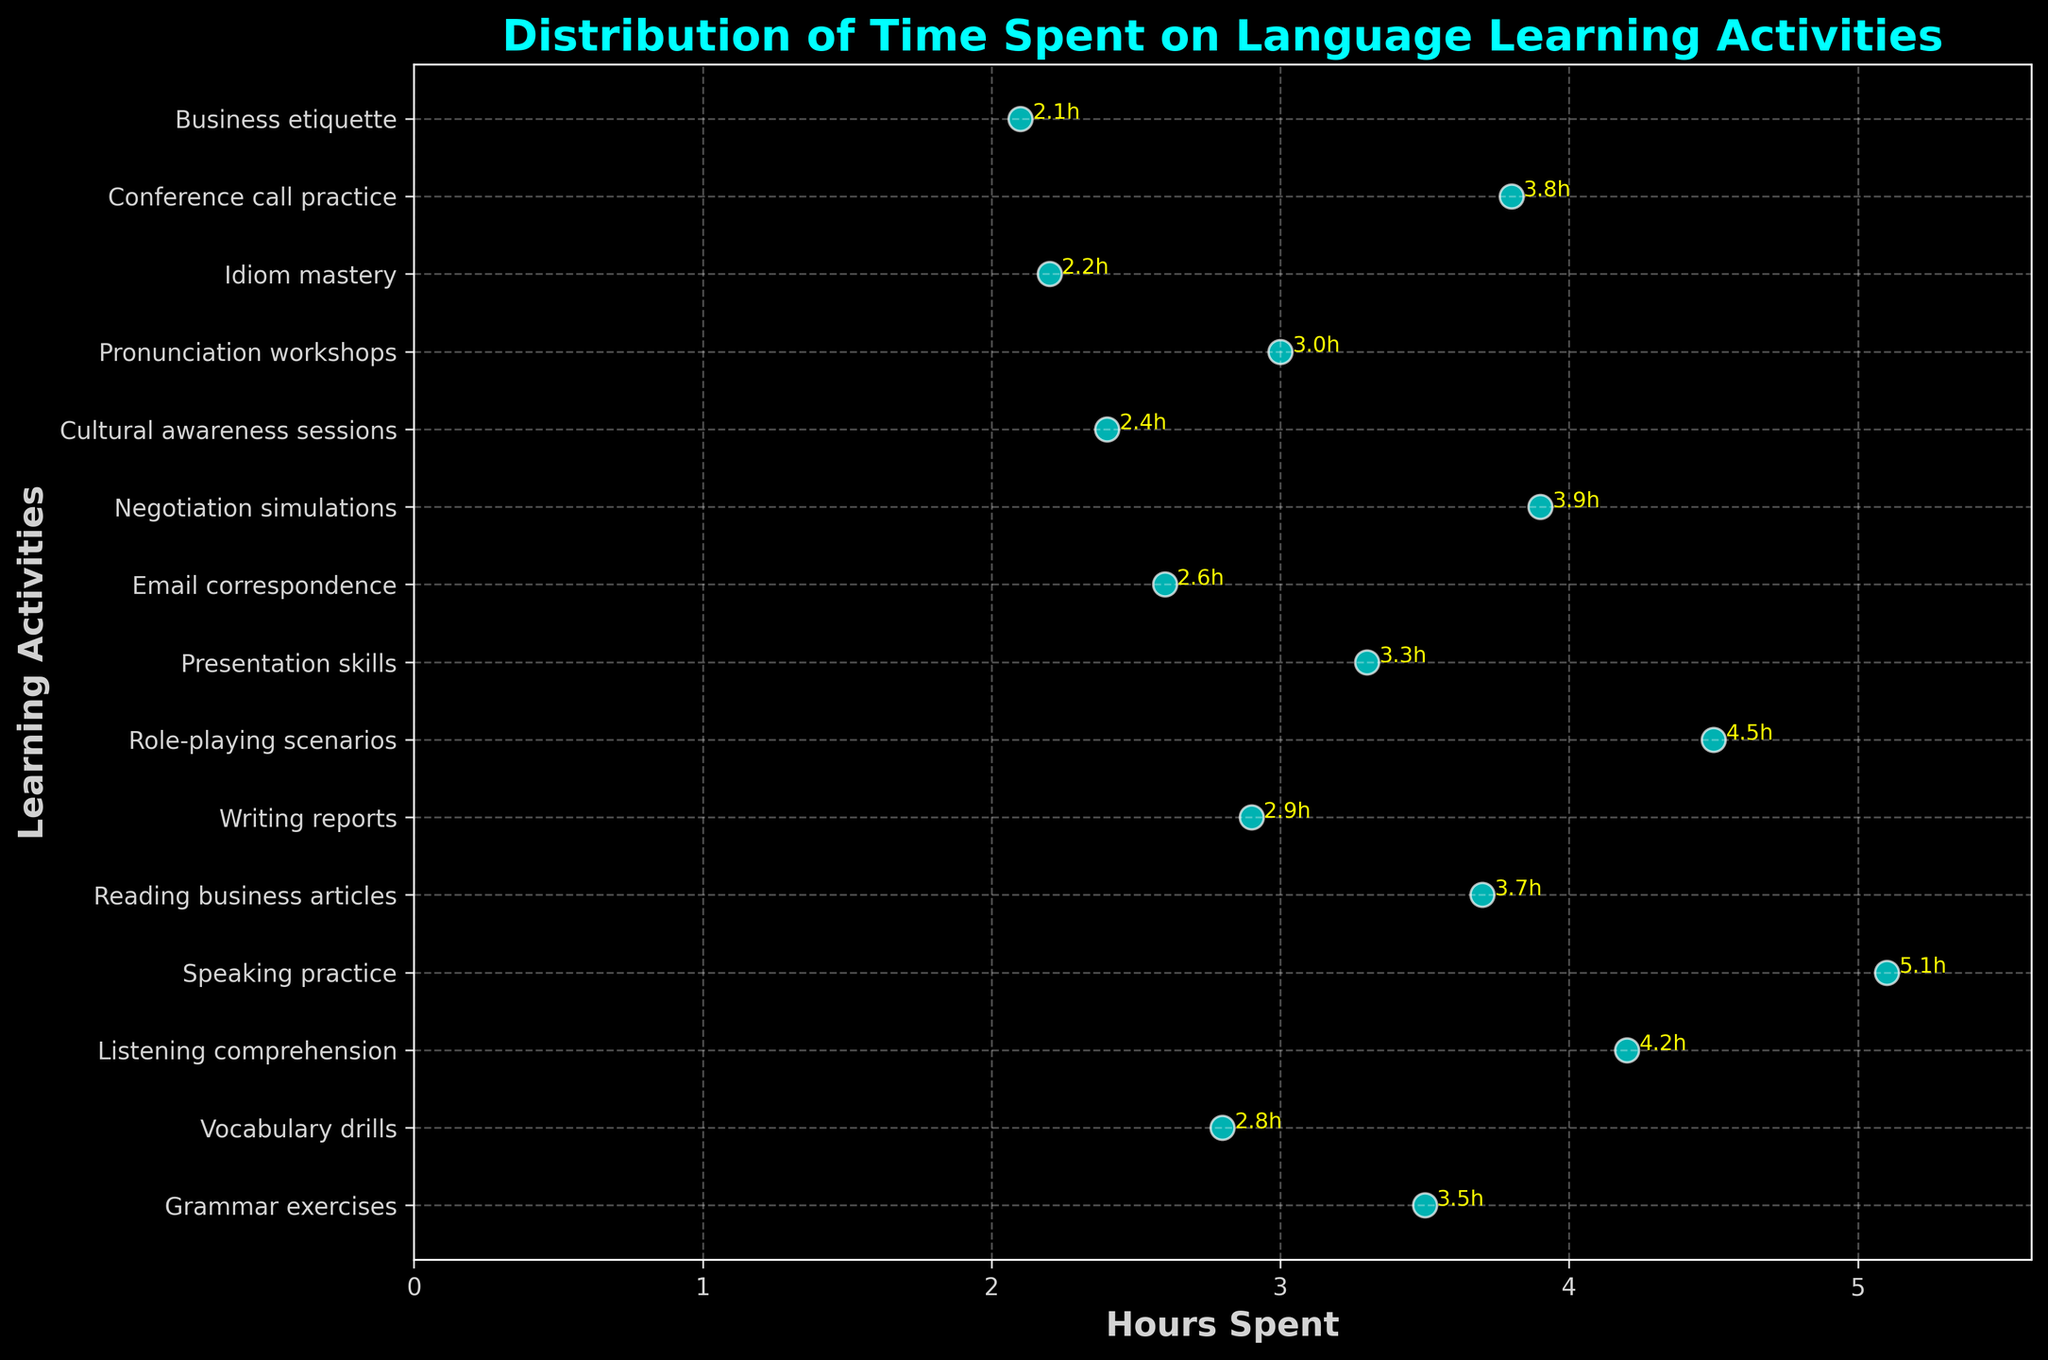What is the title of the plot? The title is located at the top of the plot and it describes what the plot is about.
Answer: Distribution of Time Spent on Language Learning Activities How many different learning activities are listed on the plot? Count the number of unique activity labels on the y-axis.
Answer: 15 What is the x-axis labeled as? The x-axis label is located along the horizontal axis and it describes the numeric values being represented.
Answer: Hours Spent Which learning activity has the highest number of hours spent? Locate the activity that is farthest to the right on the plot.
Answer: Speaking practice What is the total number of hours spent on Grammar exercises and Vocabulary drills? Locate the hours for both Grammar exercises and Vocabulary drills on the plot and add them together: 3.5 + 2.8.
Answer: 6.3 Which activity took exactly 3.8 hours? Locate the point on the x-axis at 3.8 and identify the corresponding activity on the y-axis.
Answer: Conference call practice What is the average number of hours spent on Pronunciation workshops, Email correspondence, and Business etiquette? Add the hours spent on each activity and divide by the number of activities: (3.0 + 2.6 + 2.1) / 3.
Answer: 2.57 How many activities took less than 3 hours to complete? Identify and count the number of activities that have points to the left of the 3-hour mark on the x-axis.
Answer: 7 Which activity has the least amount of time spent on it? Locate the activity that is farthest to the left on the plot.
Answer: Cultural awareness sessions How many activities took more than 4 hours to complete? Identify and count the activities that have points to the right of the 4-hour mark on the x-axis.
Answer: 3 